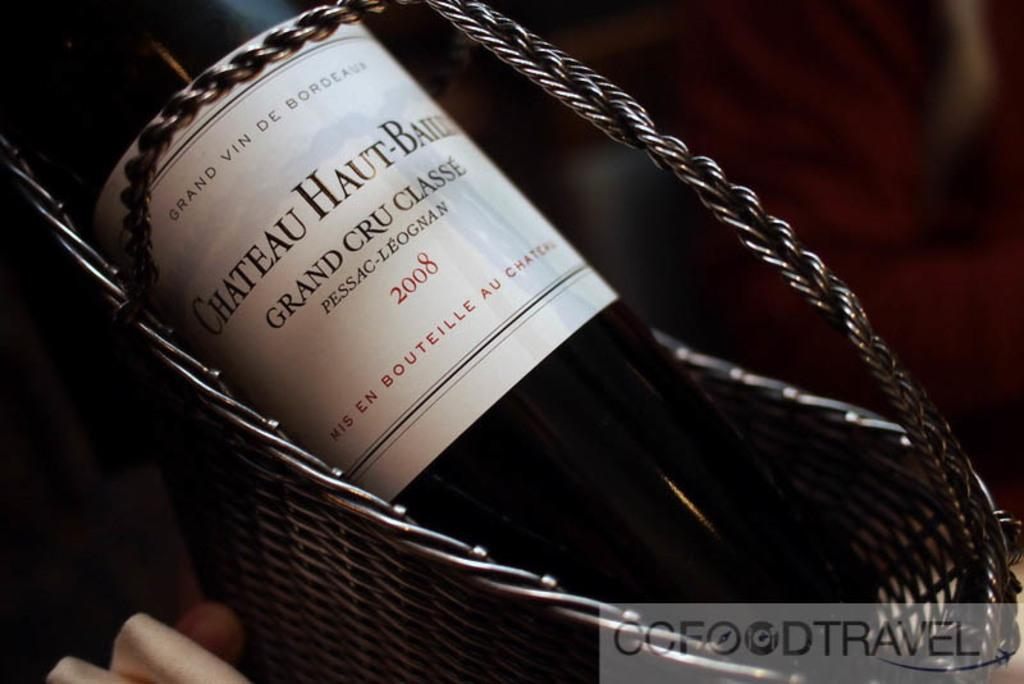Provide a one-sentence caption for the provided image. A bottle of 2008 Grand Cru Classe in a basket. 